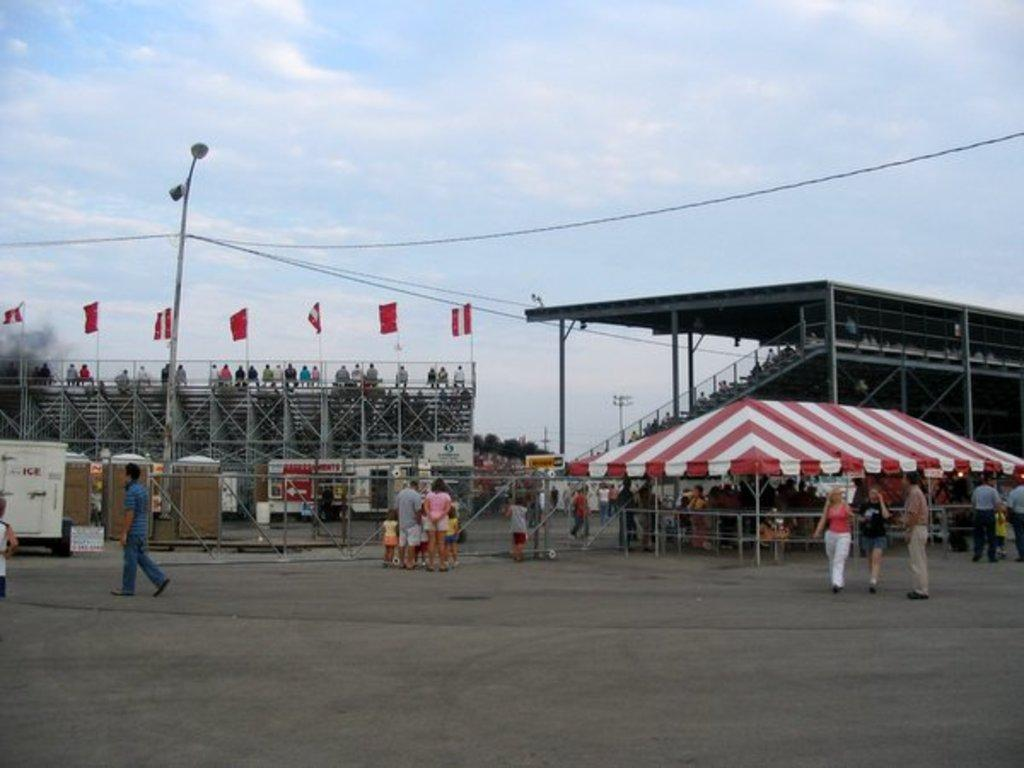What structure is located on the right side of the image? There is a shed on the right side of the image. What are the people in the image doing? The people in the image are walking and standing. What can be seen flying in the image? There are flags visible in the image. What is visible at the top of the image? The sky is visible at the top of the image. How long does it take for the glue to dry in the image? There is no glue present in the image, so it is not possible to determine how long it would take for it to dry. What type of minute can be seen in the image? There are no minutes present in the image; it features a shed, people, flags, and the sky. 